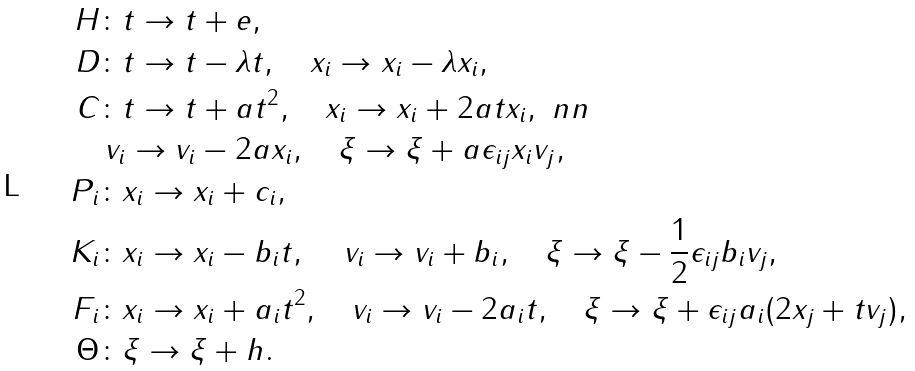<formula> <loc_0><loc_0><loc_500><loc_500>H & \colon t \to t + e , \\ D & \colon t \to t - \lambda t , \quad x _ { i } \to x _ { i } - \lambda x _ { i } , \\ C & \colon t \to t + a t ^ { 2 } , \quad x _ { i } \to x _ { i } + 2 a t x _ { i } , \ n n \\ & \, v _ { i } \to v _ { i } - 2 a x _ { i } , \quad \xi \to \xi + a \epsilon _ { i j } x _ { i } v _ { j } , \\ P _ { i } & \colon x _ { i } \to x _ { i } + c _ { i } , \\ K _ { i } & \colon x _ { i } \to x _ { i } - b _ { i } t , \quad \, v _ { i } \to v _ { i } + b _ { i } , \quad \xi \to \xi - \frac { 1 } { 2 } \epsilon _ { i j } b _ { i } v _ { j } , \\ F _ { i } & \colon x _ { i } \to x _ { i } + a _ { i } t ^ { 2 } , \quad v _ { i } \to v _ { i } - 2 a _ { i } t , \quad \xi \to \xi + \epsilon _ { i j } a _ { i } ( 2 x _ { j } + t v _ { j } ) , \\ \Theta & \colon \xi \to \xi + h .</formula> 